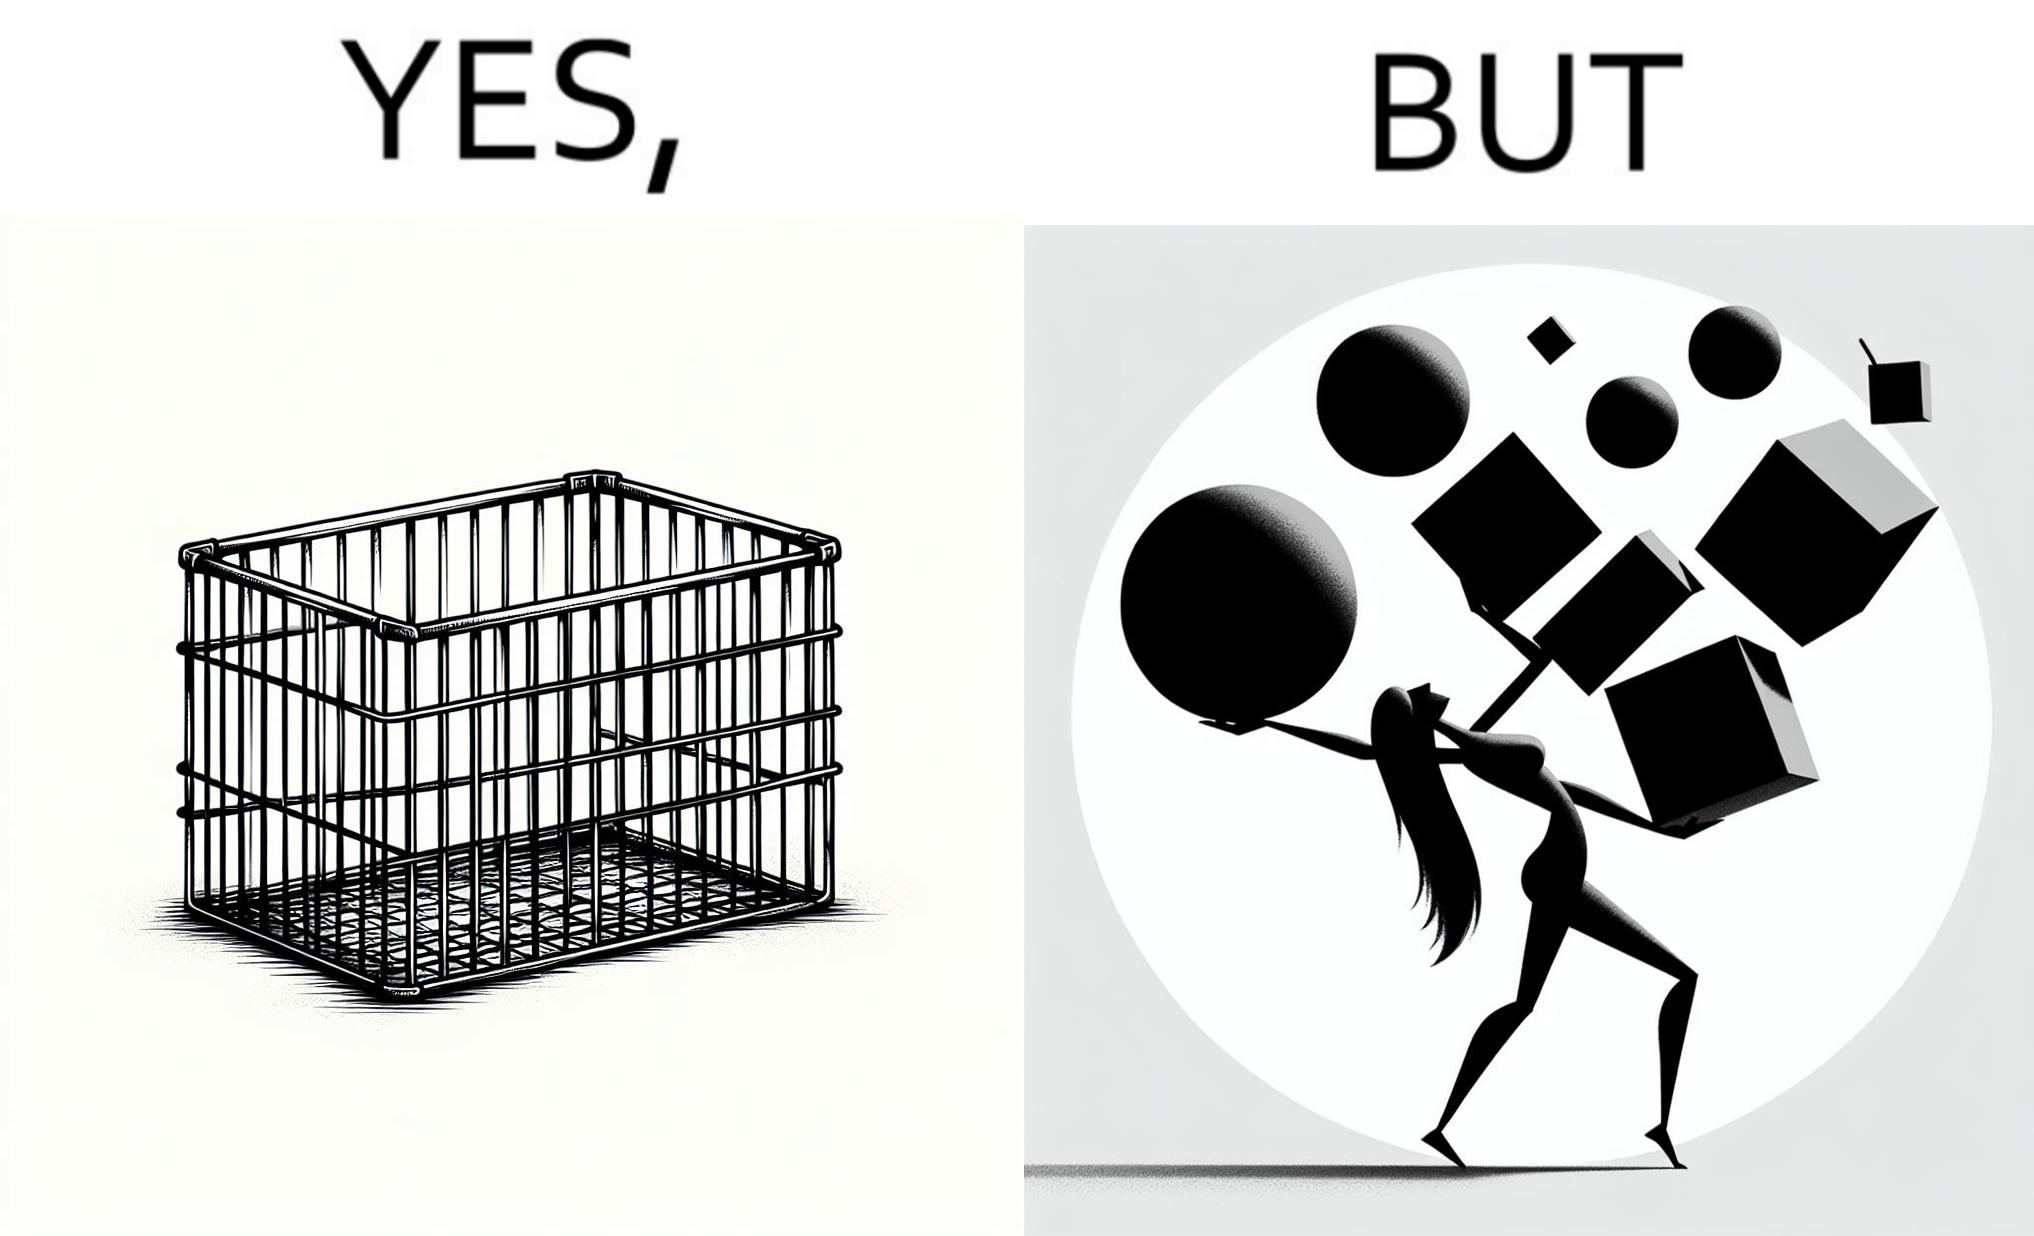Describe what you see in this image. The image is ironic, because even when there are steel frame baskets are available at the supermarkets people prefer carrying the items in hand 